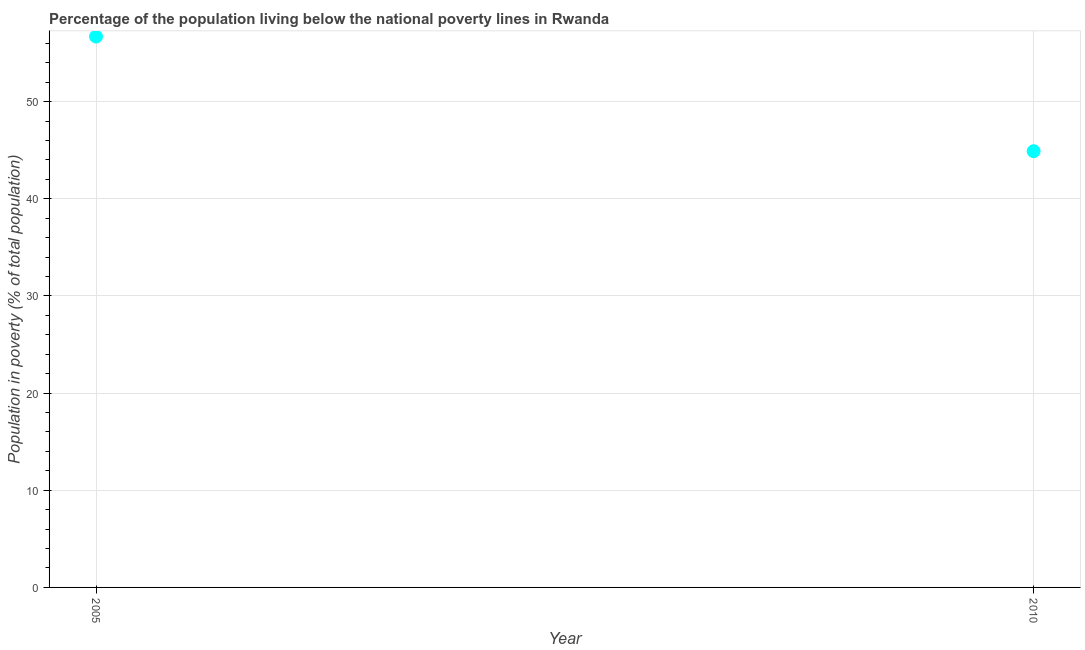What is the percentage of population living below poverty line in 2010?
Give a very brief answer. 44.9. Across all years, what is the maximum percentage of population living below poverty line?
Make the answer very short. 56.7. Across all years, what is the minimum percentage of population living below poverty line?
Offer a very short reply. 44.9. In which year was the percentage of population living below poverty line maximum?
Ensure brevity in your answer.  2005. What is the sum of the percentage of population living below poverty line?
Ensure brevity in your answer.  101.6. What is the difference between the percentage of population living below poverty line in 2005 and 2010?
Your answer should be very brief. 11.8. What is the average percentage of population living below poverty line per year?
Keep it short and to the point. 50.8. What is the median percentage of population living below poverty line?
Give a very brief answer. 50.8. What is the ratio of the percentage of population living below poverty line in 2005 to that in 2010?
Make the answer very short. 1.26. Does the percentage of population living below poverty line monotonically increase over the years?
Offer a very short reply. No. How many years are there in the graph?
Your answer should be very brief. 2. What is the difference between two consecutive major ticks on the Y-axis?
Ensure brevity in your answer.  10. Does the graph contain any zero values?
Keep it short and to the point. No. Does the graph contain grids?
Provide a succinct answer. Yes. What is the title of the graph?
Offer a very short reply. Percentage of the population living below the national poverty lines in Rwanda. What is the label or title of the X-axis?
Make the answer very short. Year. What is the label or title of the Y-axis?
Your answer should be very brief. Population in poverty (% of total population). What is the Population in poverty (% of total population) in 2005?
Your response must be concise. 56.7. What is the Population in poverty (% of total population) in 2010?
Provide a succinct answer. 44.9. What is the difference between the Population in poverty (% of total population) in 2005 and 2010?
Ensure brevity in your answer.  11.8. What is the ratio of the Population in poverty (% of total population) in 2005 to that in 2010?
Make the answer very short. 1.26. 